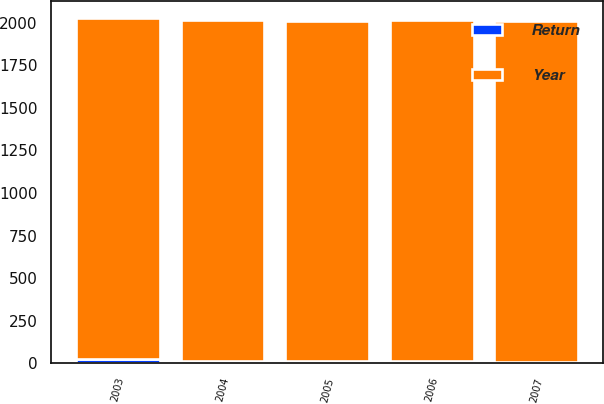<chart> <loc_0><loc_0><loc_500><loc_500><stacked_bar_chart><ecel><fcel>2007<fcel>2006<fcel>2005<fcel>2004<fcel>2003<nl><fcel>Return<fcel>9.6<fcel>14.9<fcel>11.7<fcel>14.1<fcel>26<nl><fcel>Year<fcel>2002<fcel>2001<fcel>2000<fcel>1999<fcel>1998<nl></chart> 